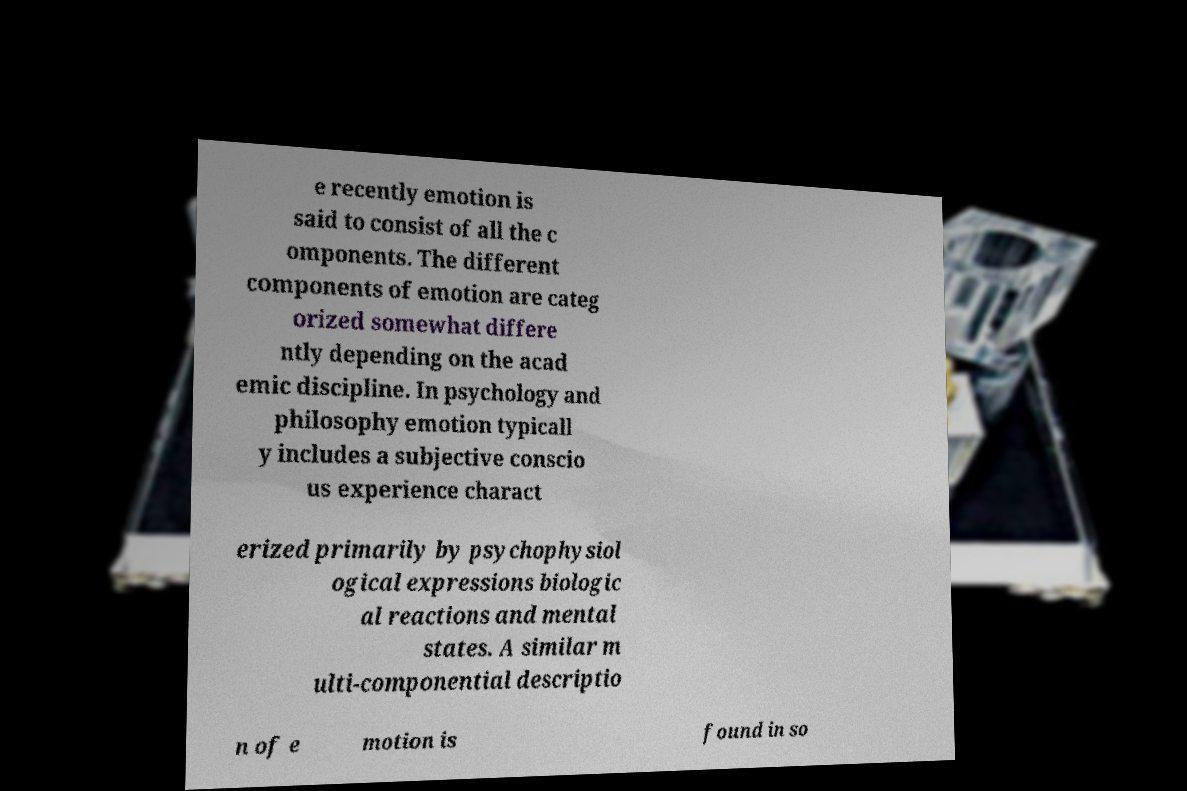What messages or text are displayed in this image? I need them in a readable, typed format. e recently emotion is said to consist of all the c omponents. The different components of emotion are categ orized somewhat differe ntly depending on the acad emic discipline. In psychology and philosophy emotion typicall y includes a subjective conscio us experience charact erized primarily by psychophysiol ogical expressions biologic al reactions and mental states. A similar m ulti-componential descriptio n of e motion is found in so 